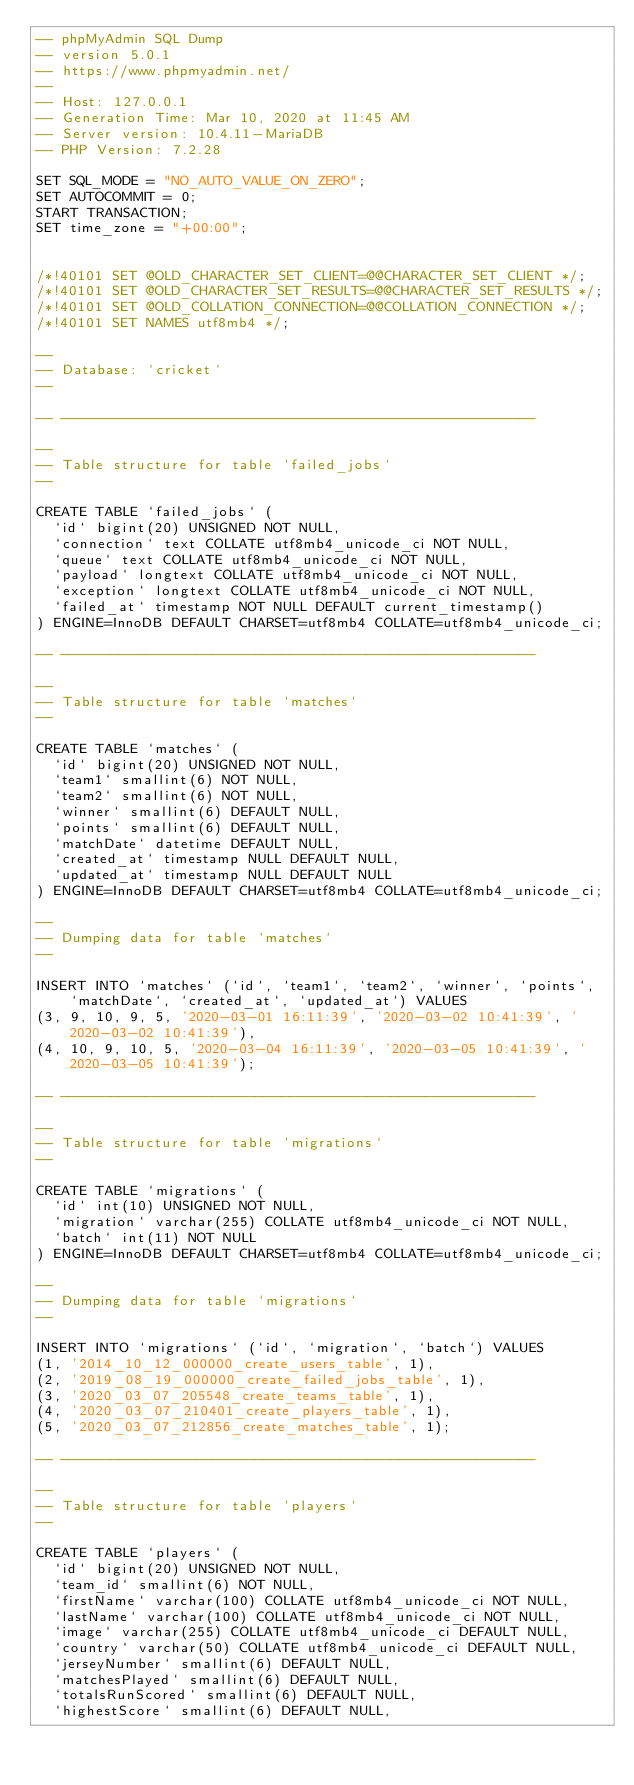<code> <loc_0><loc_0><loc_500><loc_500><_SQL_>-- phpMyAdmin SQL Dump
-- version 5.0.1
-- https://www.phpmyadmin.net/
--
-- Host: 127.0.0.1
-- Generation Time: Mar 10, 2020 at 11:45 AM
-- Server version: 10.4.11-MariaDB
-- PHP Version: 7.2.28

SET SQL_MODE = "NO_AUTO_VALUE_ON_ZERO";
SET AUTOCOMMIT = 0;
START TRANSACTION;
SET time_zone = "+00:00";


/*!40101 SET @OLD_CHARACTER_SET_CLIENT=@@CHARACTER_SET_CLIENT */;
/*!40101 SET @OLD_CHARACTER_SET_RESULTS=@@CHARACTER_SET_RESULTS */;
/*!40101 SET @OLD_COLLATION_CONNECTION=@@COLLATION_CONNECTION */;
/*!40101 SET NAMES utf8mb4 */;

--
-- Database: `cricket`
--

-- --------------------------------------------------------

--
-- Table structure for table `failed_jobs`
--

CREATE TABLE `failed_jobs` (
  `id` bigint(20) UNSIGNED NOT NULL,
  `connection` text COLLATE utf8mb4_unicode_ci NOT NULL,
  `queue` text COLLATE utf8mb4_unicode_ci NOT NULL,
  `payload` longtext COLLATE utf8mb4_unicode_ci NOT NULL,
  `exception` longtext COLLATE utf8mb4_unicode_ci NOT NULL,
  `failed_at` timestamp NOT NULL DEFAULT current_timestamp()
) ENGINE=InnoDB DEFAULT CHARSET=utf8mb4 COLLATE=utf8mb4_unicode_ci;

-- --------------------------------------------------------

--
-- Table structure for table `matches`
--

CREATE TABLE `matches` (
  `id` bigint(20) UNSIGNED NOT NULL,
  `team1` smallint(6) NOT NULL,
  `team2` smallint(6) NOT NULL,
  `winner` smallint(6) DEFAULT NULL,
  `points` smallint(6) DEFAULT NULL,
  `matchDate` datetime DEFAULT NULL,
  `created_at` timestamp NULL DEFAULT NULL,
  `updated_at` timestamp NULL DEFAULT NULL
) ENGINE=InnoDB DEFAULT CHARSET=utf8mb4 COLLATE=utf8mb4_unicode_ci;

--
-- Dumping data for table `matches`
--

INSERT INTO `matches` (`id`, `team1`, `team2`, `winner`, `points`, `matchDate`, `created_at`, `updated_at`) VALUES
(3, 9, 10, 9, 5, '2020-03-01 16:11:39', '2020-03-02 10:41:39', '2020-03-02 10:41:39'),
(4, 10, 9, 10, 5, '2020-03-04 16:11:39', '2020-03-05 10:41:39', '2020-03-05 10:41:39');

-- --------------------------------------------------------

--
-- Table structure for table `migrations`
--

CREATE TABLE `migrations` (
  `id` int(10) UNSIGNED NOT NULL,
  `migration` varchar(255) COLLATE utf8mb4_unicode_ci NOT NULL,
  `batch` int(11) NOT NULL
) ENGINE=InnoDB DEFAULT CHARSET=utf8mb4 COLLATE=utf8mb4_unicode_ci;

--
-- Dumping data for table `migrations`
--

INSERT INTO `migrations` (`id`, `migration`, `batch`) VALUES
(1, '2014_10_12_000000_create_users_table', 1),
(2, '2019_08_19_000000_create_failed_jobs_table', 1),
(3, '2020_03_07_205548_create_teams_table', 1),
(4, '2020_03_07_210401_create_players_table', 1),
(5, '2020_03_07_212856_create_matches_table', 1);

-- --------------------------------------------------------

--
-- Table structure for table `players`
--

CREATE TABLE `players` (
  `id` bigint(20) UNSIGNED NOT NULL,
  `team_id` smallint(6) NOT NULL,
  `firstName` varchar(100) COLLATE utf8mb4_unicode_ci NOT NULL,
  `lastName` varchar(100) COLLATE utf8mb4_unicode_ci NOT NULL,
  `image` varchar(255) COLLATE utf8mb4_unicode_ci DEFAULT NULL,
  `country` varchar(50) COLLATE utf8mb4_unicode_ci DEFAULT NULL,
  `jerseyNumber` smallint(6) DEFAULT NULL,
  `matchesPlayed` smallint(6) DEFAULT NULL,
  `totalsRunScored` smallint(6) DEFAULT NULL,
  `highestScore` smallint(6) DEFAULT NULL,</code> 